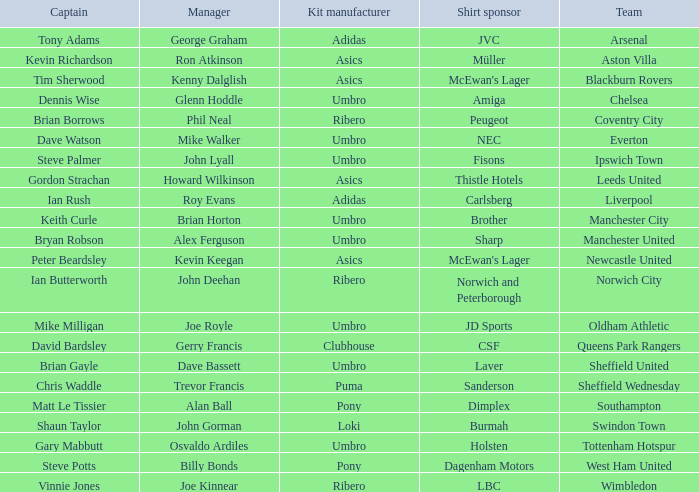Which manager has Manchester City as the team? Brian Horton. 